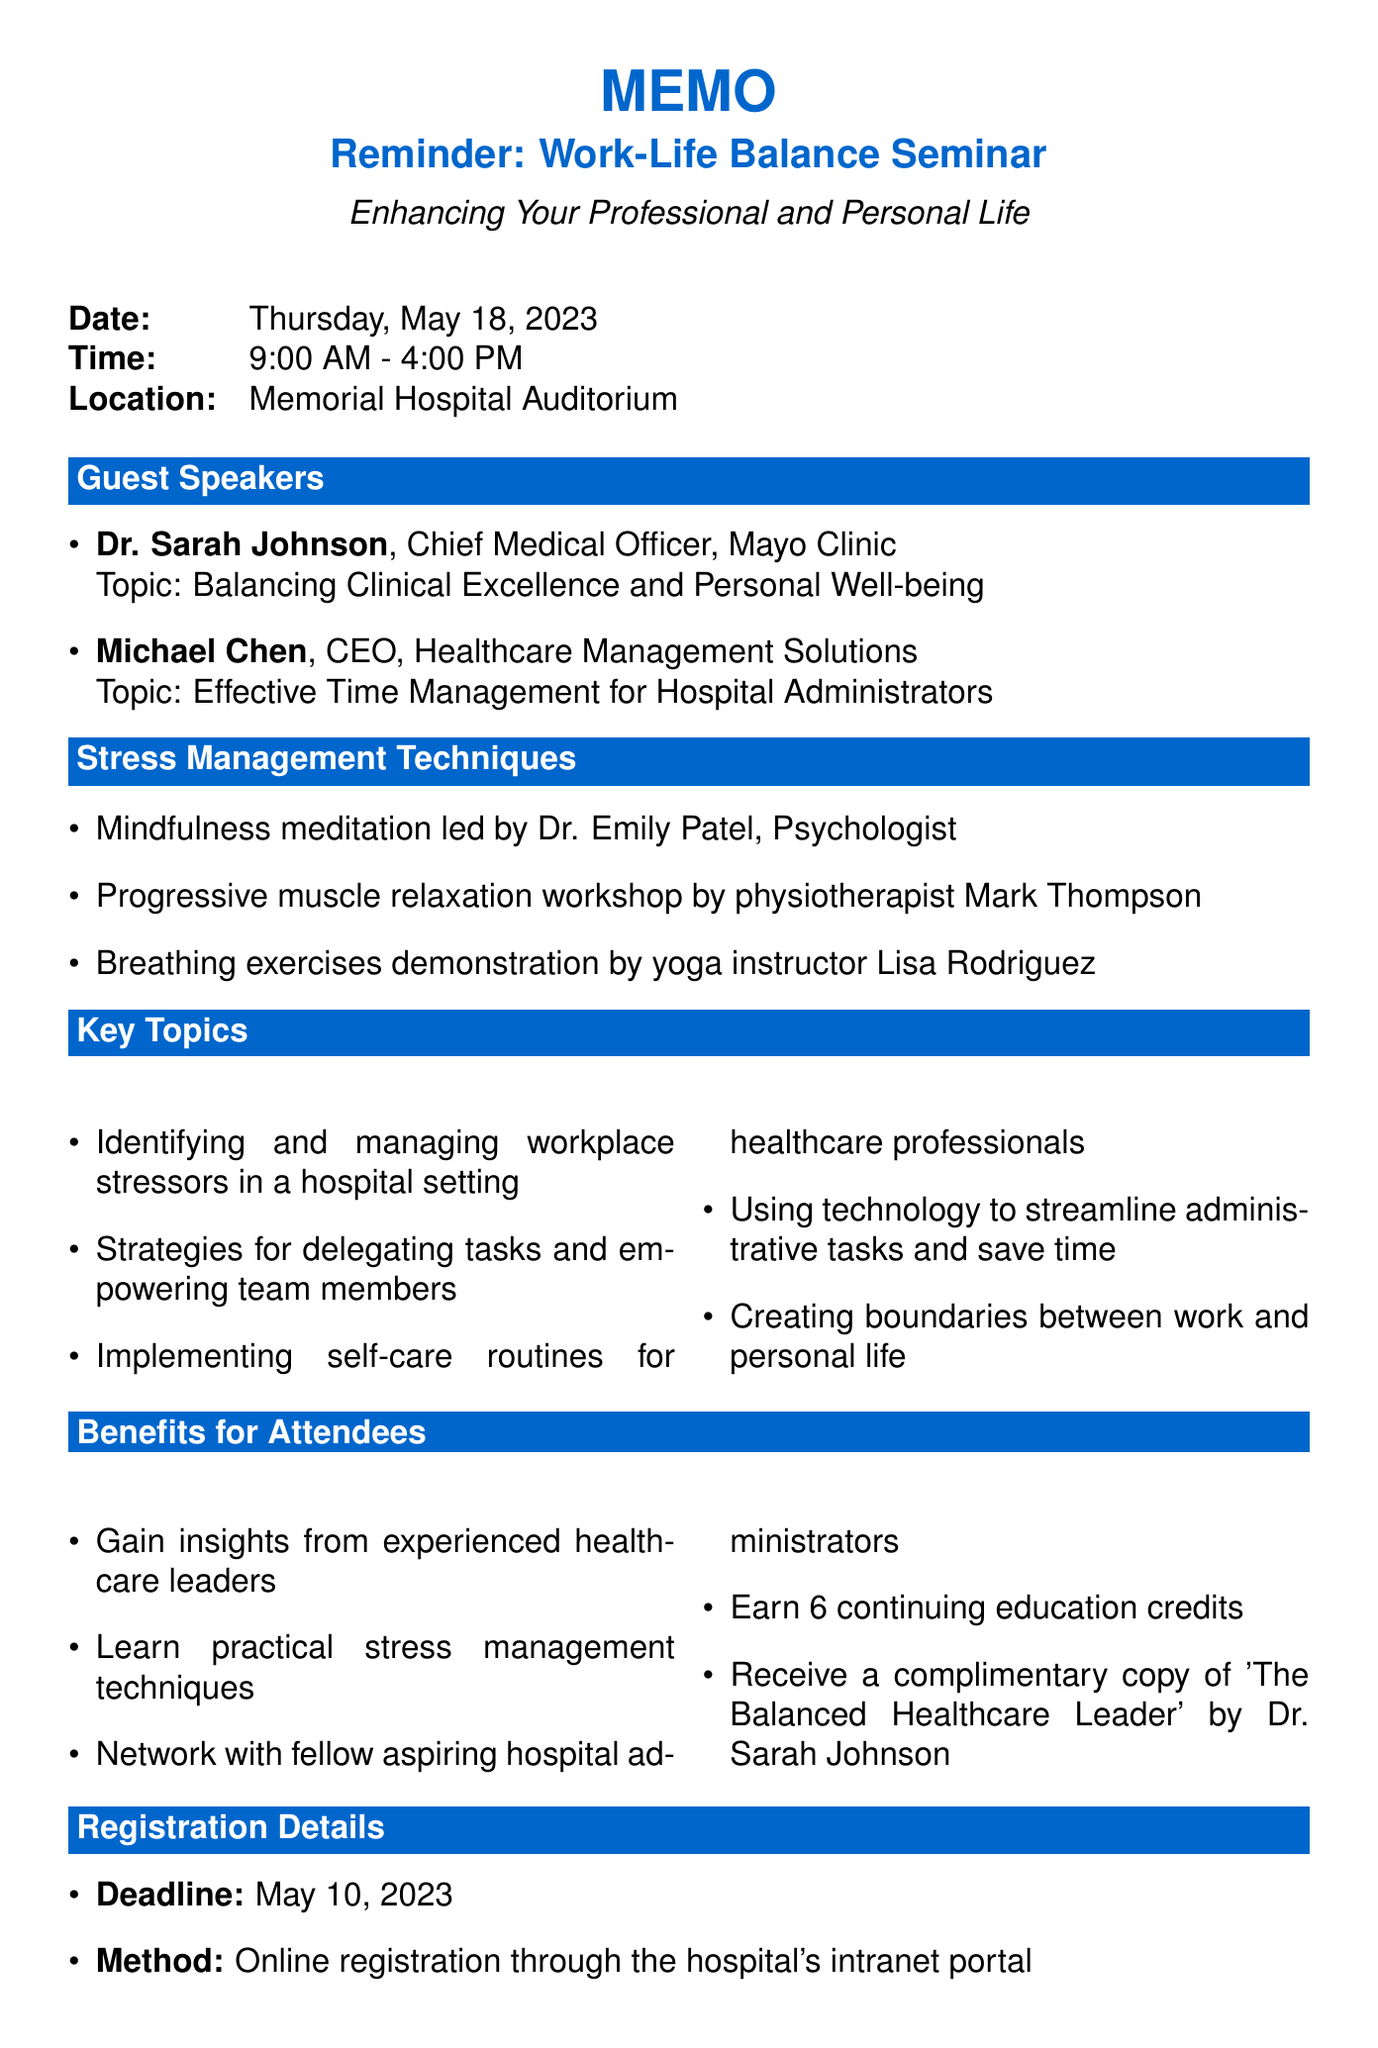What is the date of the seminar? The seminar is scheduled for Thursday, May 18, 2023.
Answer: Thursday, May 18, 2023 Who is the guest speaker addressing time management? Michael Chen will be discussing effective time management techniques.
Answer: Michael Chen What is one of the key topics to be discussed? The document lists several topics, one of which is "Identifying and managing workplace stressors in a hospital setting."
Answer: Identifying and managing workplace stressors in a hospital setting How many continuing education credits can attendees earn? Attendees can earn 6 continuing education credits for participating in the seminar.
Answer: 6 What is the deadline for registration? The deadline for registration is indicated in the document as May 10, 2023.
Answer: May 10, 2023 Who should attendees contact for questions regarding registration? The contact person for registration questions is Jessica Lee, HR Coordinator, as mentioned in the document.
Answer: Jessica Lee What is recommended attire for the seminar? The memo recommends business casual attire for attendees.
Answer: Business casual What is one of the stress management techniques mentioned? One of the techniques included in the seminar is mindfulness meditation led by Dr. Emily Patel.
Answer: Mindfulness meditation 